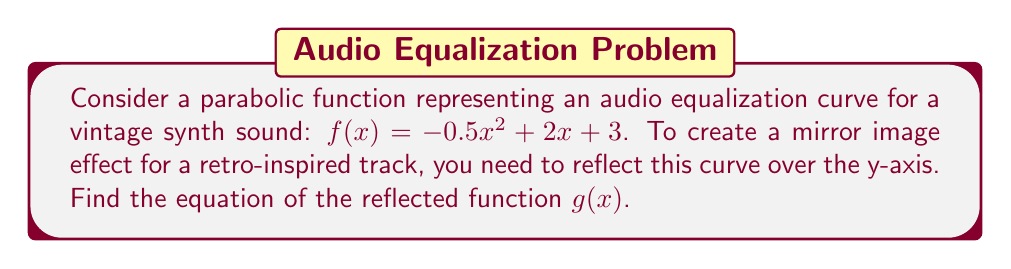Show me your answer to this math problem. To reflect a function over the y-axis, we replace every $x$ with $-x$ in the original function. Let's go through this step-by-step:

1) Start with the original function: $f(x) = -0.5x^2 + 2x + 3$

2) Replace every $x$ with $-x$:
   $g(x) = -0.5(-x)^2 + 2(-x) + 3$

3) Simplify:
   - $(-x)^2 = x^2$ (squaring a negative number gives a positive result)
   - $2(-x) = -2x$

4) Therefore:
   $g(x) = -0.5x^2 - 2x + 3$

The resulting function $g(x)$ is the reflection of $f(x)$ over the y-axis, creating a mirror image effect that could be used to design a symmetrical equalization curve for a retro-inspired audio track.
Answer: $g(x) = -0.5x^2 - 2x + 3$ 